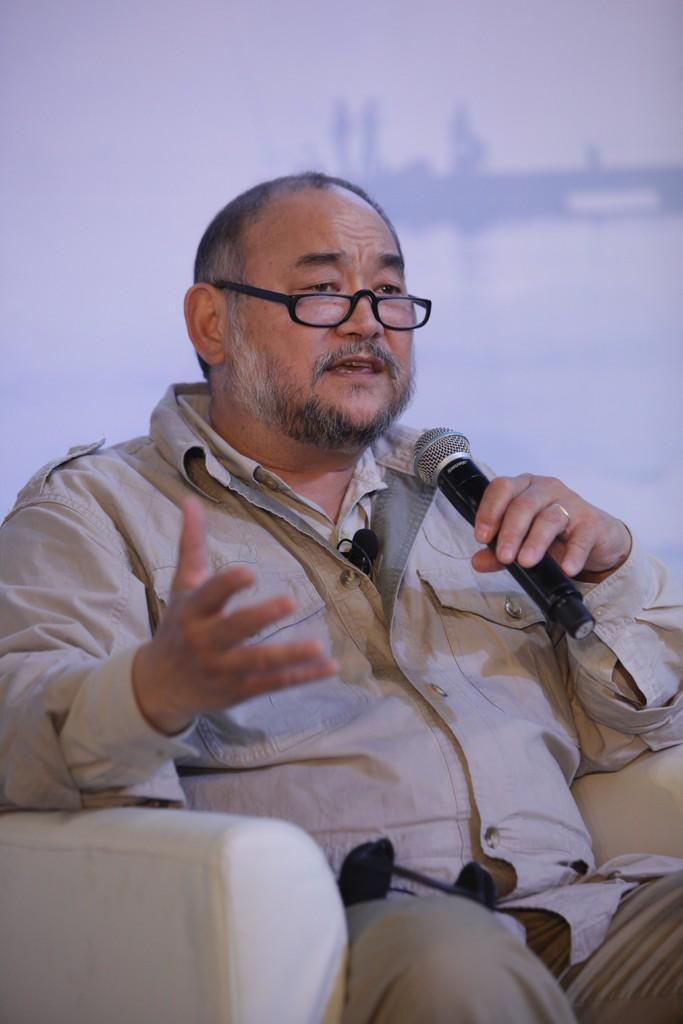Can you describe this image briefly? In the image we can see the man sitting, he is wearing clothes, spectacles, finger ring and the man is holding a microphone in hand, and the background is blurred. 